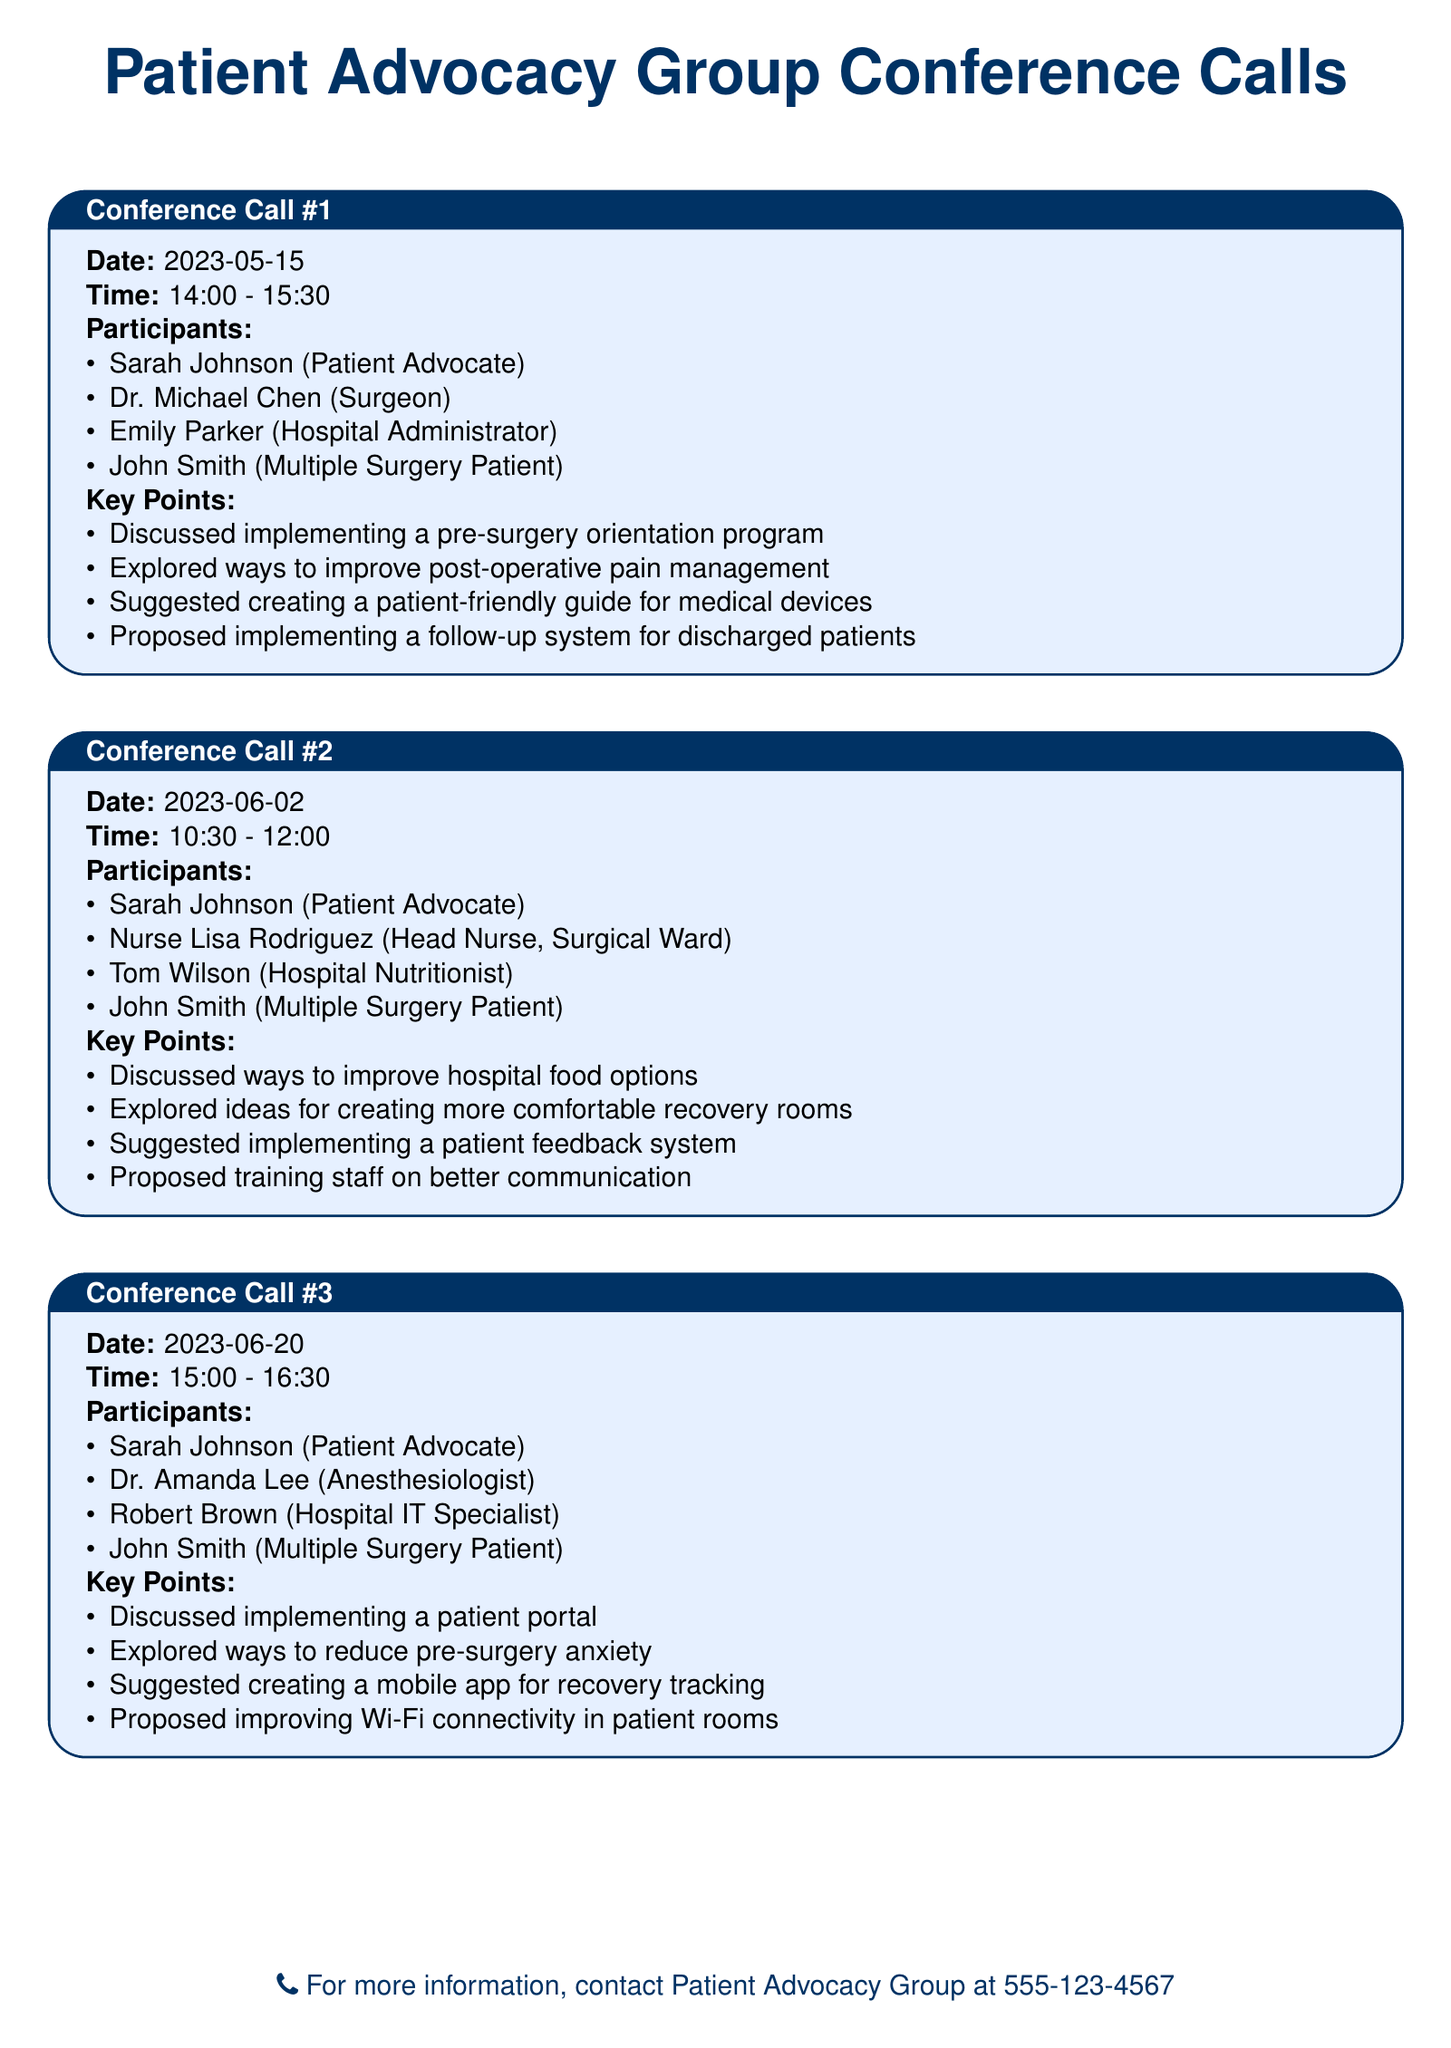what is the date of the first conference call? The date of the first conference call is listed in the document as May 15, 2023.
Answer: 2023-05-15 who is the participant from the surgical ward in the second conference call? The participant from the surgical ward in the second conference call is Nurse Lisa Rodriguez.
Answer: Nurse Lisa Rodriguez what is one of the key points discussed in the third conference call? One key point discussed in the third conference call is that the group explored ways to reduce pre-surgery anxiety.
Answer: Explored ways to reduce pre-surgery anxiety how many participants are listed in the first conference call? The first conference call lists four participants in total.
Answer: 4 which medical professional participated in the first conference call? The medical professional who participated in the first conference call is Dr. Michael Chen.
Answer: Dr. Michael Chen what was suggested to improve communication among staff? The suggestion made to improve communication among staff was to train staff on better communication.
Answer: Proposed training staff on better communication what was discussed regarding food options in the second conference call? In the second conference call, the group discussed ways to improve hospital food options.
Answer: Discussed ways to improve hospital food options how was patient feedback proposed to be collected? The document suggests implementing a patient feedback system.
Answer: Suggested implementing a patient feedback system 